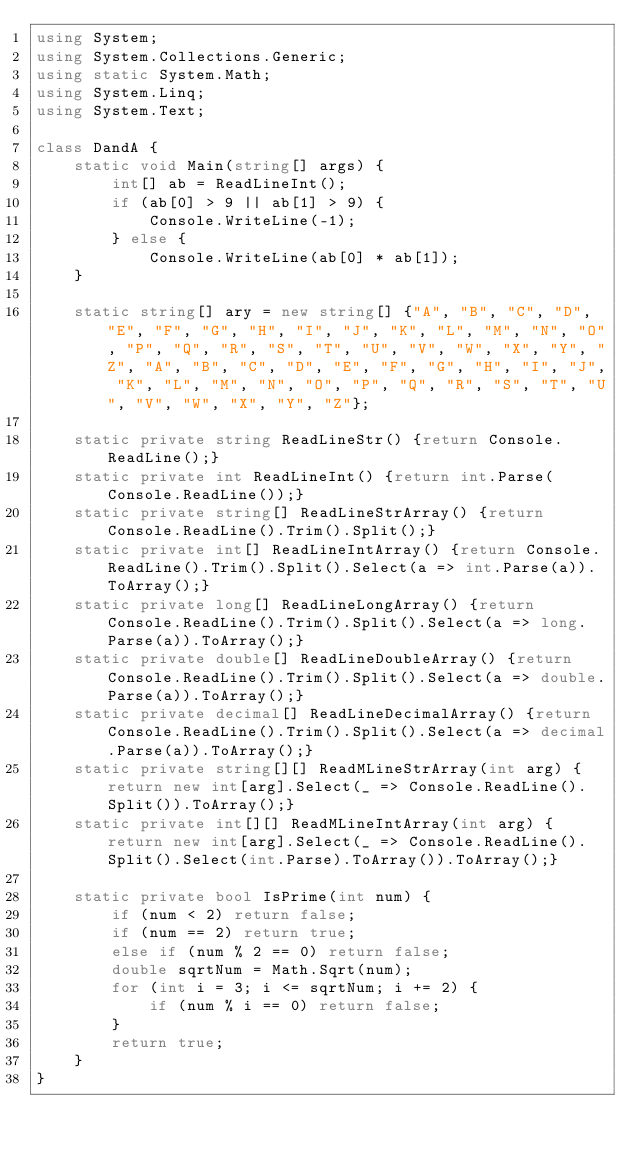<code> <loc_0><loc_0><loc_500><loc_500><_C#_>using System;
using System.Collections.Generic;
using static System.Math;
using System.Linq;
using System.Text;

class DandA {
    static void Main(string[] args) {
        int[] ab = ReadLineInt();
        if (ab[0] > 9 || ab[1] > 9) {
            Console.WriteLine(-1);
        } else {
            Console.WriteLine(ab[0] * ab[1]);
    }

    static string[] ary = new string[] {"A", "B", "C", "D", "E", "F", "G", "H", "I", "J", "K", "L", "M", "N", "O", "P", "Q", "R", "S", "T", "U", "V", "W", "X", "Y", "Z", "A", "B", "C", "D", "E", "F", "G", "H", "I", "J", "K", "L", "M", "N", "O", "P", "Q", "R", "S", "T", "U", "V", "W", "X", "Y", "Z"};
  
    static private string ReadLineStr() {return Console.ReadLine();}
    static private int ReadLineInt() {return int.Parse(Console.ReadLine());}
    static private string[] ReadLineStrArray() {return Console.ReadLine().Trim().Split();}
    static private int[] ReadLineIntArray() {return Console.ReadLine().Trim().Split().Select(a => int.Parse(a)).ToArray();}
    static private long[] ReadLineLongArray() {return Console.ReadLine().Trim().Split().Select(a => long.Parse(a)).ToArray();}
    static private double[] ReadLineDoubleArray() {return Console.ReadLine().Trim().Split().Select(a => double.Parse(a)).ToArray();}
    static private decimal[] ReadLineDecimalArray() {return Console.ReadLine().Trim().Split().Select(a => decimal.Parse(a)).ToArray();}
    static private string[][] ReadMLineStrArray(int arg) { return new int[arg].Select(_ => Console.ReadLine().Split()).ToArray();}
    static private int[][] ReadMLineIntArray(int arg) { return new int[arg].Select(_ => Console.ReadLine().Split().Select(int.Parse).ToArray()).ToArray();}

    static private bool IsPrime(int num) {
        if (num < 2) return false;
        if (num == 2) return true;
        else if (num % 2 == 0) return false;
        double sqrtNum = Math.Sqrt(num);
        for (int i = 3; i <= sqrtNum; i += 2) {
            if (num % i == 0) return false;
        }
        return true;
    }
}</code> 